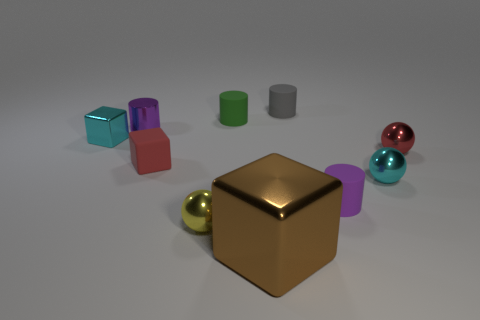Subtract all gray cylinders. How many cylinders are left? 3 Subtract all small yellow spheres. How many spheres are left? 2 Subtract 3 cylinders. How many cylinders are left? 1 Add 5 cyan shiny balls. How many cyan shiny balls exist? 6 Subtract 0 yellow cylinders. How many objects are left? 10 Subtract all spheres. How many objects are left? 7 Subtract all yellow cubes. Subtract all red cylinders. How many cubes are left? 3 Subtract all cyan spheres. How many gray cylinders are left? 1 Subtract all purple rubber cylinders. Subtract all large brown things. How many objects are left? 8 Add 8 purple metallic objects. How many purple metallic objects are left? 9 